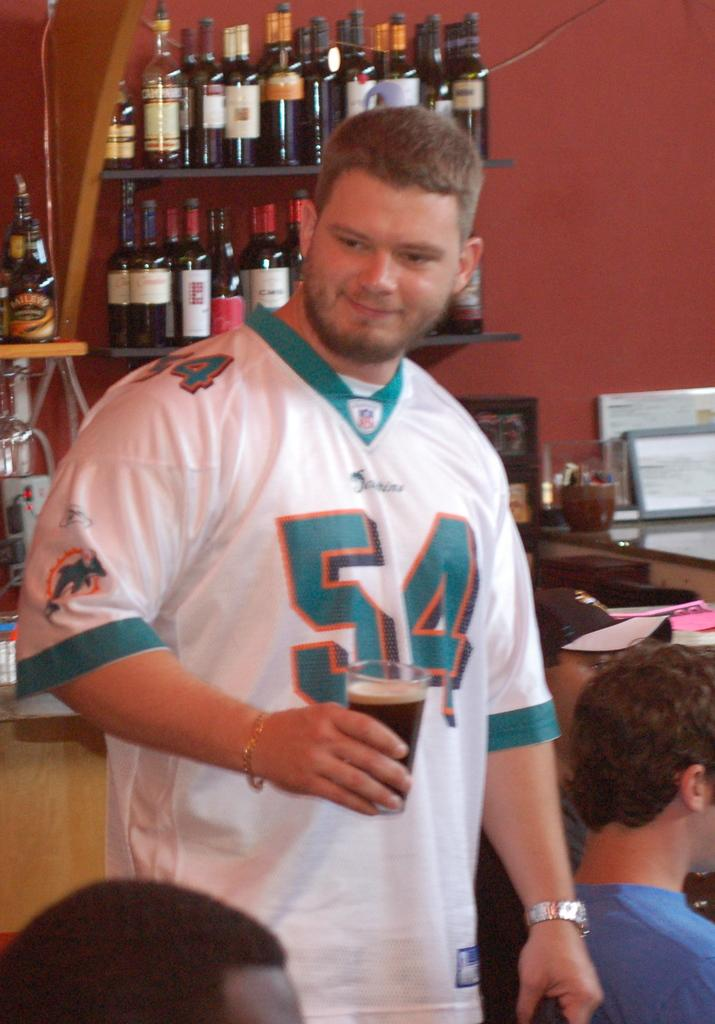<image>
Relay a brief, clear account of the picture shown. a man in 54 jersey smiles at someone down below 